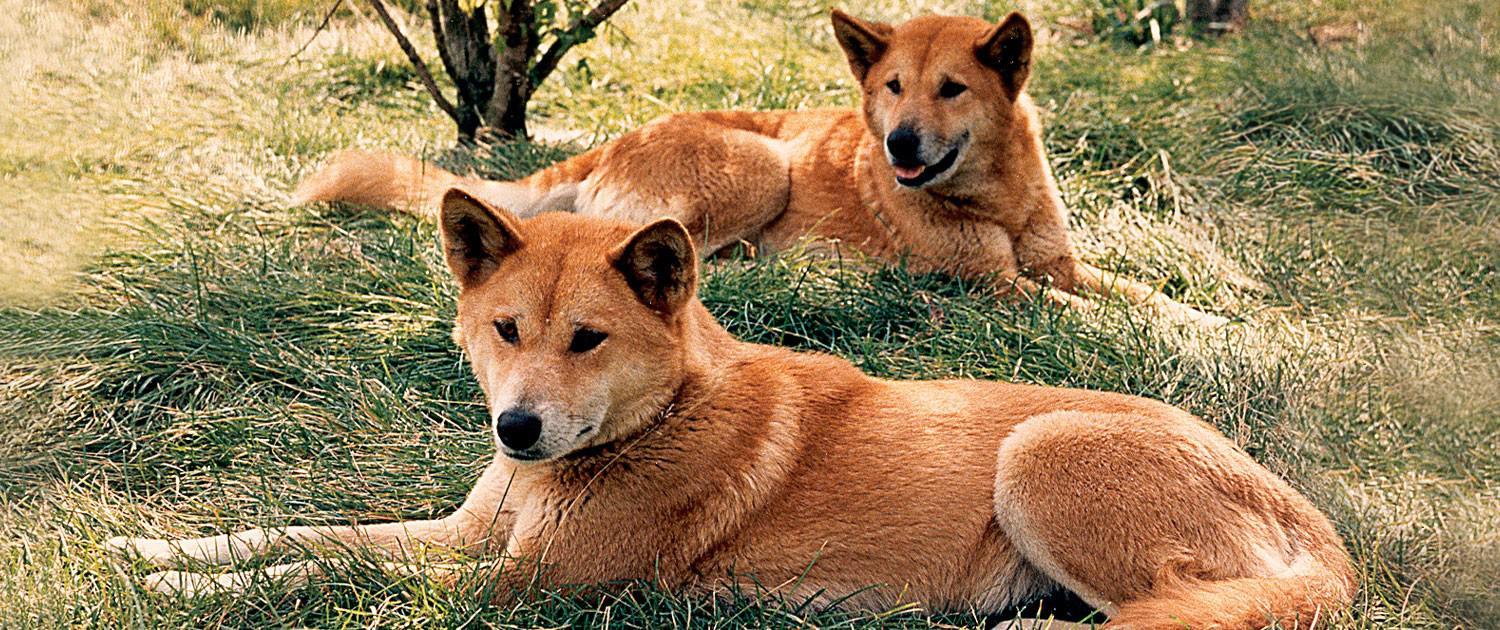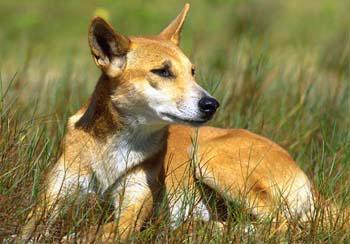The first image is the image on the left, the second image is the image on the right. Given the left and right images, does the statement "There are two dogs" hold true? Answer yes or no. No. The first image is the image on the left, the second image is the image on the right. Considering the images on both sides, is "Left image shows two dogs and right image shows one dog." valid? Answer yes or no. Yes. 